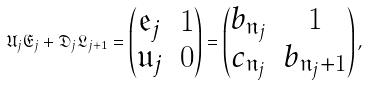Convert formula to latex. <formula><loc_0><loc_0><loc_500><loc_500>\mathfrak { U } _ { j } \mathfrak { E } _ { j } + \mathfrak { D } _ { j } \mathfrak { L } _ { j + 1 } = \begin{pmatrix} { \mathfrak e } _ { j } & 1 \\ { \mathfrak u } _ { j } & 0 \\ \end{pmatrix} = \begin{pmatrix} b _ { \mathfrak { n } _ { j } } & 1 \\ { c } _ { \mathfrak { n } _ { j } } & b _ { \mathfrak { n } _ { j } + 1 } \\ \end{pmatrix} ,</formula> 